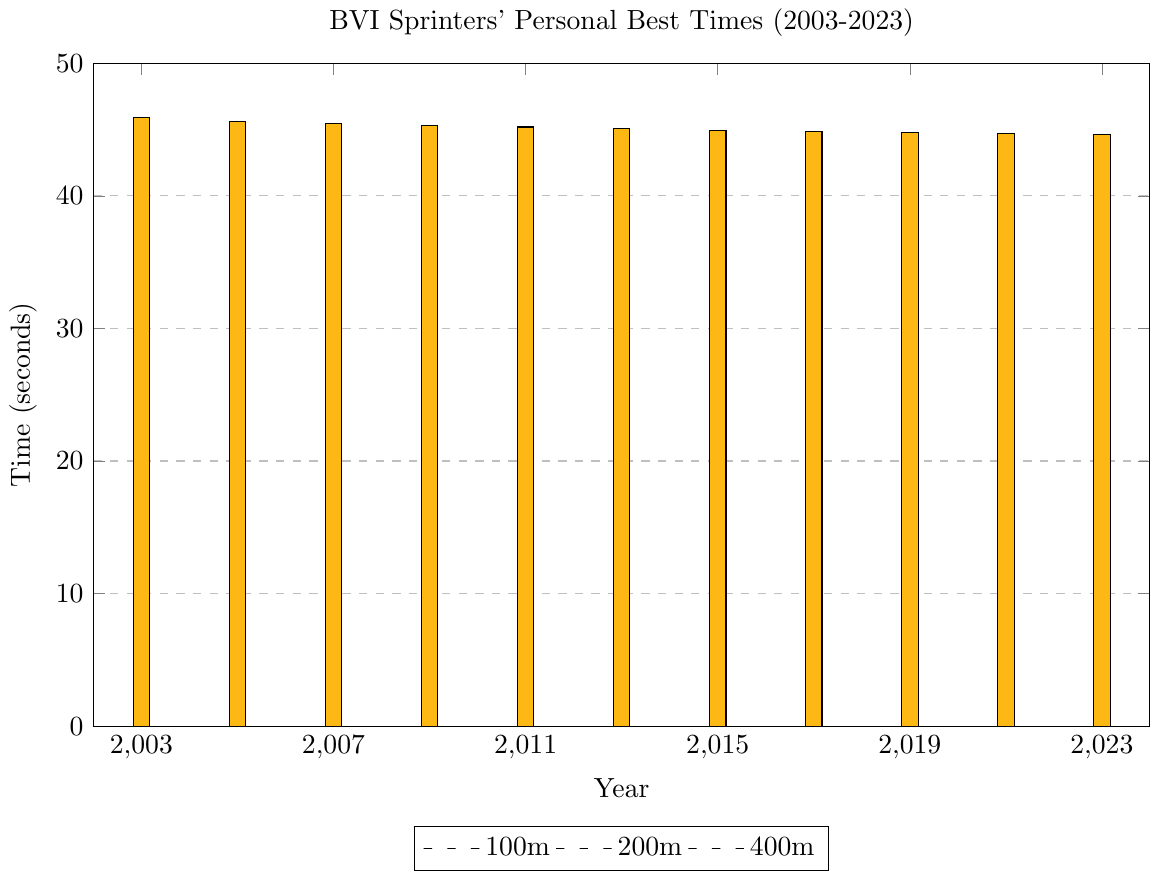Which sprint event showed the most significant improvement in personal best times over the 20 years? To determine this, we need to consider the difference between the 2003 and 2023 times for each event. For the 100m, it improved from 10.21s to 9.96s (a decrease of 0.25s). For the 200m, it improved from 20.58s to 19.83s (a decrease of 0.75s). For the 400m, it improved from 45.89s to 44.62s (a decrease of 1.27s). The 400m event showed the most significant improvement.
Answer: 400m Which year had the best overall performance for the sprinters (lowest combined times for 100m, 200m, and 400m)? Calculate the combined times for 100m, 200m, and 400m for each year: 
2003: 10.21 + 20.58 + 45.89 = 76.68s 
2005: 10.18 + 20.42 + 45.62 = 76.22s 
2007: 10.15 + 20.36 + 45.45 = 75.96s 
2009: 10.11 + 20.25 + 45.31 = 75.67s 
2011: 10.08 + 20.18 + 45.19 = 75.45s 
2013: 10.05 + 20.11 + 45.07 = 75.23s 
2015: 10.03 + 20.05 + 44.96 = 75.04s 
2017: 10.01 + 19.98 + 44.85 = 74.84s 
2019: 9.99 + 19.92 + 44.76 = 74.67s 
2021: 9.97 + 19.87 + 44.68 = 74.52s 
2023: 9.96 + 19.83 + 44.62 = 74.41s 
2023 had the best overall performance with the lowest combined time.
Answer: 2023 Which event had the slowest improvement rate over the 20 years? Improvement rate can be evaluated by the difference in times from 2003 to 2023. For the 100m, the improvement is 10.21 - 9.96 = 0.25s. For the 200m, it is 20.58 - 19.83 = 0.75s. For the 400m, it is 45.89 - 44.62 = 1.27s. The 100m event had the slowest improvement rate.
Answer: 100m How did the personal best time in the 100m event change from 2011 to 2013? To find the change, subtract the 2013 time from the 2011 time. 10.08s (2011) - 10.05s (2013) = 0.03s. The personal best time improved by 0.03 seconds.
Answer: Improved by 0.03s Between 2005 and 2017, which event had the smallest decrease in time? Subtract the 2005 times from the 2017 times for each event. 
100m: 10.18 - 10.01 = 0.17s 
200m: 20.42 - 19.98 = 0.44s 
400m: 45.62 - 44.85 = 0.77s 
The 100m event had the smallest decrease in time.
Answer: 100m How many years did it take for the 100m personal best time to drop below 10 seconds? Identify the first year when the 100m time was below 10 seconds. The 100m time first dropped below 10 seconds in 2019 (9.99s). The starting year is 2003. 
2019 - 2003 = 16 years.
Answer: 16 years Which event consistently showed improvement in every recorded year? Check if the times show consistent improvement (decreasing) every year for each event. The 100m, 200m, and 400m events all showed consistent improvement each year.
Answer: 100m, 200m, 400m Compare the improvement in the 200m event from 2003 to 2009 with that from 2009 to 2023. Which period saw more improvement? Calculate the decrease in time for both periods. 
2003-2009: 20.58s - 20.25s = 0.33s 
2009-2023: 20.25s - 19.83s = 0.42s 
The period from 2009 to 2023 saw more improvement.
Answer: 2009-2023 